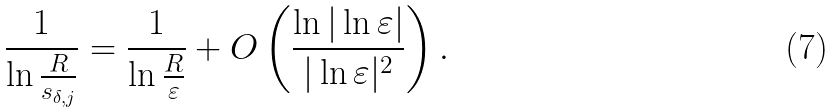<formula> <loc_0><loc_0><loc_500><loc_500>\frac { 1 } { \ln \frac { R } { s _ { \delta , j } } } = \frac { 1 } { \ln \frac { R } { \varepsilon } } + O \left ( \frac { \ln | \ln \varepsilon | } { | \ln \varepsilon | ^ { 2 } } \right ) .</formula> 